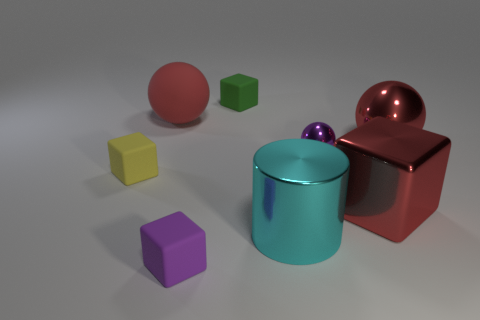What number of large red matte spheres are in front of the small thing that is on the left side of the large red rubber ball? 0 